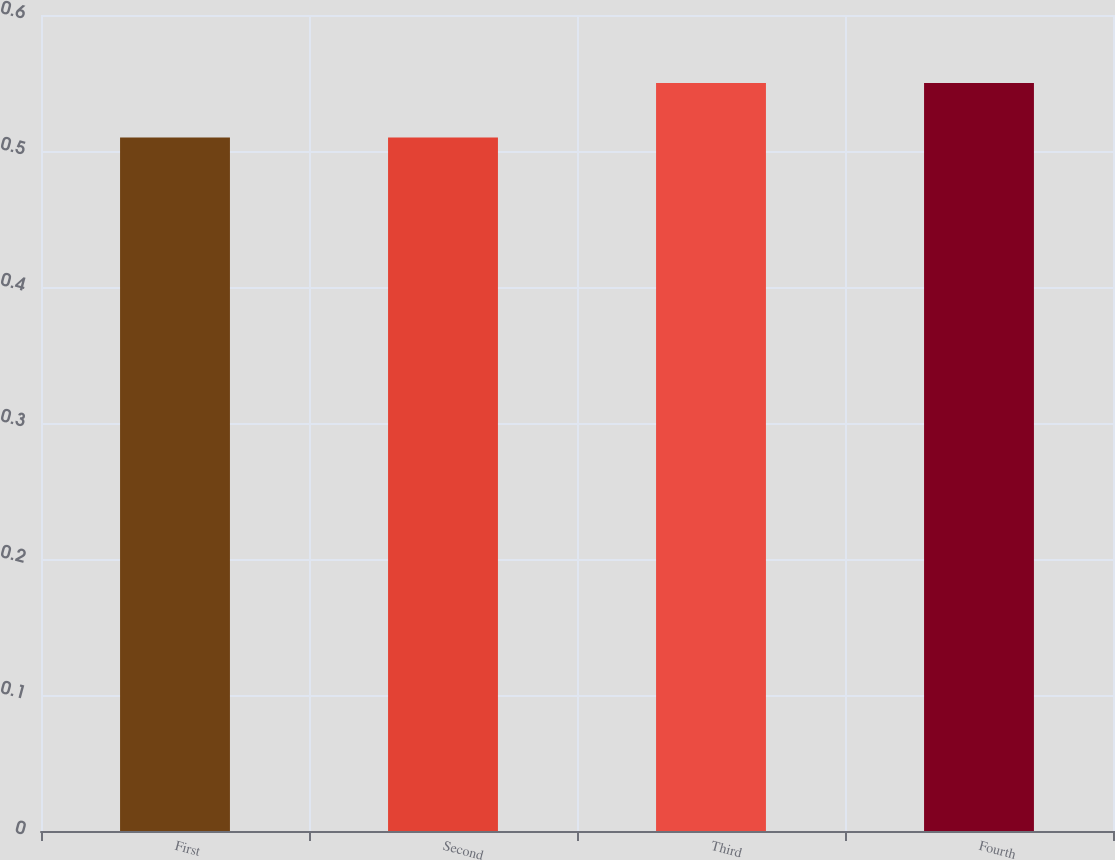Convert chart to OTSL. <chart><loc_0><loc_0><loc_500><loc_500><bar_chart><fcel>First<fcel>Second<fcel>Third<fcel>Fourth<nl><fcel>0.51<fcel>0.51<fcel>0.55<fcel>0.55<nl></chart> 